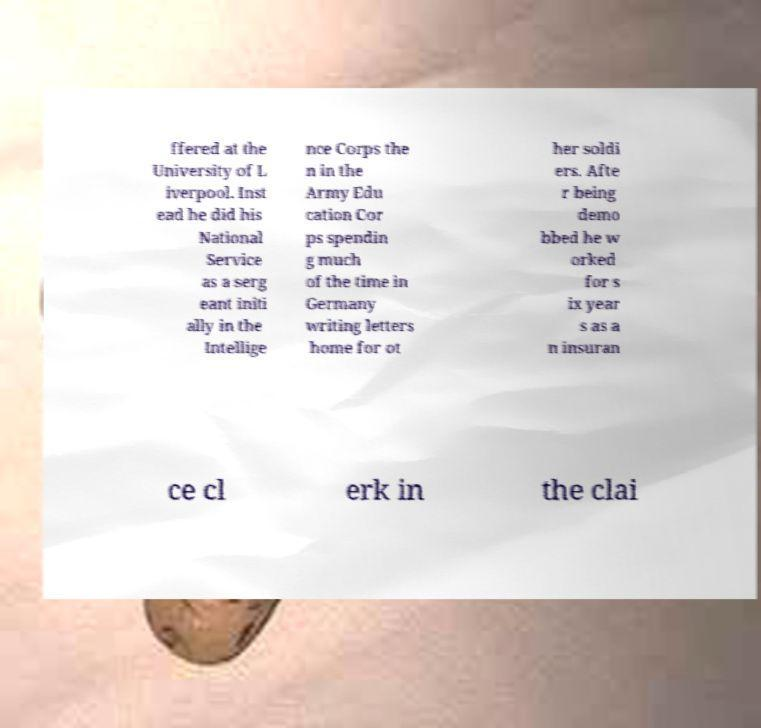I need the written content from this picture converted into text. Can you do that? ffered at the University of L iverpool. Inst ead he did his National Service as a serg eant initi ally in the Intellige nce Corps the n in the Army Edu cation Cor ps spendin g much of the time in Germany writing letters home for ot her soldi ers. Afte r being demo bbed he w orked for s ix year s as a n insuran ce cl erk in the clai 